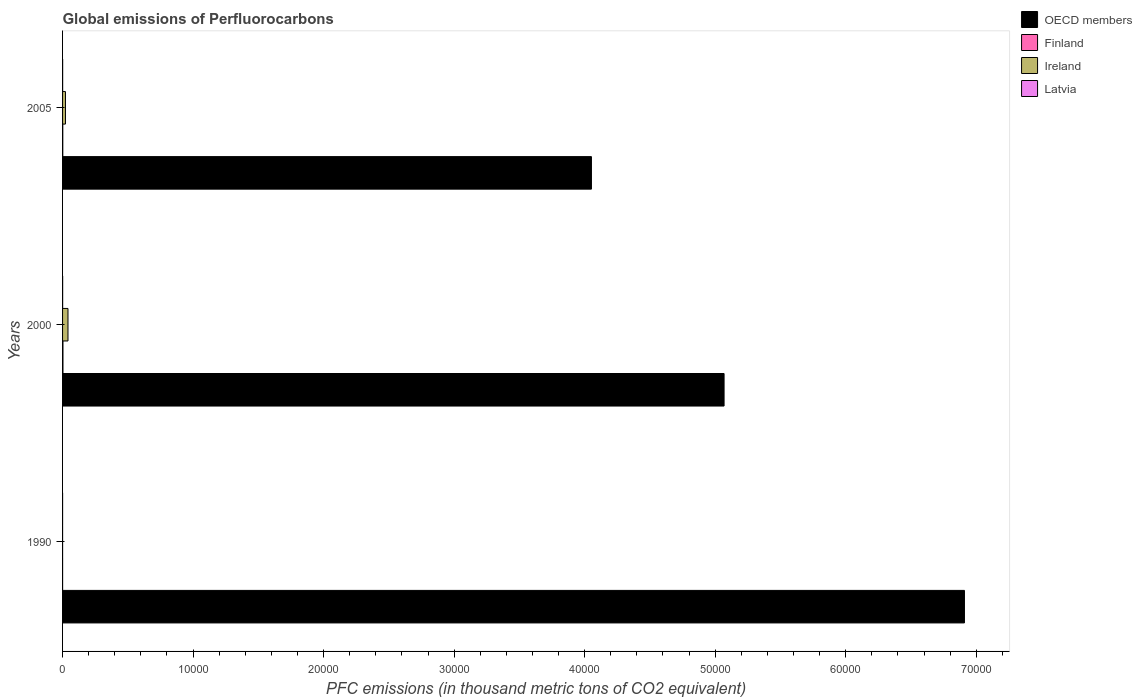How many different coloured bars are there?
Provide a short and direct response. 4. How many groups of bars are there?
Offer a terse response. 3. Are the number of bars on each tick of the Y-axis equal?
Your answer should be compact. Yes. What is the label of the 2nd group of bars from the top?
Make the answer very short. 2000. In how many cases, is the number of bars for a given year not equal to the number of legend labels?
Your answer should be very brief. 0. What is the global emissions of Perfluorocarbons in Ireland in 2005?
Your answer should be compact. 221.8. Across all years, what is the maximum global emissions of Perfluorocarbons in Latvia?
Your response must be concise. 5.7. Across all years, what is the minimum global emissions of Perfluorocarbons in OECD members?
Offer a very short reply. 4.05e+04. In which year was the global emissions of Perfluorocarbons in OECD members maximum?
Provide a succinct answer. 1990. What is the total global emissions of Perfluorocarbons in Ireland in the graph?
Ensure brevity in your answer.  638.8. What is the difference between the global emissions of Perfluorocarbons in Latvia in 1990 and the global emissions of Perfluorocarbons in OECD members in 2000?
Provide a succinct answer. -5.07e+04. What is the average global emissions of Perfluorocarbons in Latvia per year?
Make the answer very short. 3.97. In the year 2005, what is the difference between the global emissions of Perfluorocarbons in Finland and global emissions of Perfluorocarbons in OECD members?
Keep it short and to the point. -4.05e+04. In how many years, is the global emissions of Perfluorocarbons in OECD members greater than 58000 thousand metric tons?
Provide a succinct answer. 1. What is the ratio of the global emissions of Perfluorocarbons in OECD members in 2000 to that in 2005?
Your answer should be very brief. 1.25. Is the difference between the global emissions of Perfluorocarbons in Finland in 1990 and 2000 greater than the difference between the global emissions of Perfluorocarbons in OECD members in 1990 and 2000?
Your answer should be very brief. No. What is the difference between the highest and the second highest global emissions of Perfluorocarbons in Finland?
Ensure brevity in your answer.  13. What is the difference between the highest and the lowest global emissions of Perfluorocarbons in Finland?
Provide a short and direct response. 28. In how many years, is the global emissions of Perfluorocarbons in Ireland greater than the average global emissions of Perfluorocarbons in Ireland taken over all years?
Your response must be concise. 2. Is it the case that in every year, the sum of the global emissions of Perfluorocarbons in OECD members and global emissions of Perfluorocarbons in Latvia is greater than the sum of global emissions of Perfluorocarbons in Ireland and global emissions of Perfluorocarbons in Finland?
Offer a very short reply. No. How many years are there in the graph?
Your response must be concise. 3. What is the difference between two consecutive major ticks on the X-axis?
Offer a very short reply. 10000. Does the graph contain grids?
Provide a short and direct response. No. Where does the legend appear in the graph?
Your answer should be very brief. Top right. How many legend labels are there?
Your answer should be compact. 4. What is the title of the graph?
Provide a short and direct response. Global emissions of Perfluorocarbons. Does "Nigeria" appear as one of the legend labels in the graph?
Offer a very short reply. No. What is the label or title of the X-axis?
Your answer should be very brief. PFC emissions (in thousand metric tons of CO2 equivalent). What is the label or title of the Y-axis?
Your response must be concise. Years. What is the PFC emissions (in thousand metric tons of CO2 equivalent) in OECD members in 1990?
Keep it short and to the point. 6.91e+04. What is the PFC emissions (in thousand metric tons of CO2 equivalent) of Finland in 1990?
Ensure brevity in your answer.  1.7. What is the PFC emissions (in thousand metric tons of CO2 equivalent) of Ireland in 1990?
Your answer should be very brief. 1.4. What is the PFC emissions (in thousand metric tons of CO2 equivalent) in OECD members in 2000?
Provide a short and direct response. 5.07e+04. What is the PFC emissions (in thousand metric tons of CO2 equivalent) in Finland in 2000?
Offer a very short reply. 29.7. What is the PFC emissions (in thousand metric tons of CO2 equivalent) of Ireland in 2000?
Keep it short and to the point. 415.6. What is the PFC emissions (in thousand metric tons of CO2 equivalent) of OECD members in 2005?
Make the answer very short. 4.05e+04. What is the PFC emissions (in thousand metric tons of CO2 equivalent) of Ireland in 2005?
Offer a very short reply. 221.8. What is the PFC emissions (in thousand metric tons of CO2 equivalent) of Latvia in 2005?
Your answer should be compact. 5.5. Across all years, what is the maximum PFC emissions (in thousand metric tons of CO2 equivalent) in OECD members?
Your response must be concise. 6.91e+04. Across all years, what is the maximum PFC emissions (in thousand metric tons of CO2 equivalent) in Finland?
Offer a very short reply. 29.7. Across all years, what is the maximum PFC emissions (in thousand metric tons of CO2 equivalent) in Ireland?
Make the answer very short. 415.6. Across all years, what is the minimum PFC emissions (in thousand metric tons of CO2 equivalent) in OECD members?
Offer a very short reply. 4.05e+04. What is the total PFC emissions (in thousand metric tons of CO2 equivalent) in OECD members in the graph?
Your response must be concise. 1.60e+05. What is the total PFC emissions (in thousand metric tons of CO2 equivalent) of Finland in the graph?
Your response must be concise. 48.1. What is the total PFC emissions (in thousand metric tons of CO2 equivalent) in Ireland in the graph?
Offer a very short reply. 638.8. What is the total PFC emissions (in thousand metric tons of CO2 equivalent) of Latvia in the graph?
Your answer should be very brief. 11.9. What is the difference between the PFC emissions (in thousand metric tons of CO2 equivalent) in OECD members in 1990 and that in 2000?
Your response must be concise. 1.84e+04. What is the difference between the PFC emissions (in thousand metric tons of CO2 equivalent) of Ireland in 1990 and that in 2000?
Give a very brief answer. -414.2. What is the difference between the PFC emissions (in thousand metric tons of CO2 equivalent) in Latvia in 1990 and that in 2000?
Offer a terse response. -5. What is the difference between the PFC emissions (in thousand metric tons of CO2 equivalent) in OECD members in 1990 and that in 2005?
Keep it short and to the point. 2.86e+04. What is the difference between the PFC emissions (in thousand metric tons of CO2 equivalent) of Ireland in 1990 and that in 2005?
Ensure brevity in your answer.  -220.4. What is the difference between the PFC emissions (in thousand metric tons of CO2 equivalent) of OECD members in 2000 and that in 2005?
Offer a very short reply. 1.02e+04. What is the difference between the PFC emissions (in thousand metric tons of CO2 equivalent) in Finland in 2000 and that in 2005?
Your answer should be very brief. 13. What is the difference between the PFC emissions (in thousand metric tons of CO2 equivalent) of Ireland in 2000 and that in 2005?
Ensure brevity in your answer.  193.8. What is the difference between the PFC emissions (in thousand metric tons of CO2 equivalent) of Latvia in 2000 and that in 2005?
Your response must be concise. 0.2. What is the difference between the PFC emissions (in thousand metric tons of CO2 equivalent) in OECD members in 1990 and the PFC emissions (in thousand metric tons of CO2 equivalent) in Finland in 2000?
Keep it short and to the point. 6.91e+04. What is the difference between the PFC emissions (in thousand metric tons of CO2 equivalent) of OECD members in 1990 and the PFC emissions (in thousand metric tons of CO2 equivalent) of Ireland in 2000?
Offer a terse response. 6.87e+04. What is the difference between the PFC emissions (in thousand metric tons of CO2 equivalent) of OECD members in 1990 and the PFC emissions (in thousand metric tons of CO2 equivalent) of Latvia in 2000?
Offer a very short reply. 6.91e+04. What is the difference between the PFC emissions (in thousand metric tons of CO2 equivalent) in Finland in 1990 and the PFC emissions (in thousand metric tons of CO2 equivalent) in Ireland in 2000?
Your answer should be very brief. -413.9. What is the difference between the PFC emissions (in thousand metric tons of CO2 equivalent) in OECD members in 1990 and the PFC emissions (in thousand metric tons of CO2 equivalent) in Finland in 2005?
Offer a terse response. 6.91e+04. What is the difference between the PFC emissions (in thousand metric tons of CO2 equivalent) in OECD members in 1990 and the PFC emissions (in thousand metric tons of CO2 equivalent) in Ireland in 2005?
Provide a succinct answer. 6.89e+04. What is the difference between the PFC emissions (in thousand metric tons of CO2 equivalent) in OECD members in 1990 and the PFC emissions (in thousand metric tons of CO2 equivalent) in Latvia in 2005?
Ensure brevity in your answer.  6.91e+04. What is the difference between the PFC emissions (in thousand metric tons of CO2 equivalent) of Finland in 1990 and the PFC emissions (in thousand metric tons of CO2 equivalent) of Ireland in 2005?
Ensure brevity in your answer.  -220.1. What is the difference between the PFC emissions (in thousand metric tons of CO2 equivalent) in Finland in 1990 and the PFC emissions (in thousand metric tons of CO2 equivalent) in Latvia in 2005?
Provide a succinct answer. -3.8. What is the difference between the PFC emissions (in thousand metric tons of CO2 equivalent) of OECD members in 2000 and the PFC emissions (in thousand metric tons of CO2 equivalent) of Finland in 2005?
Your answer should be very brief. 5.07e+04. What is the difference between the PFC emissions (in thousand metric tons of CO2 equivalent) of OECD members in 2000 and the PFC emissions (in thousand metric tons of CO2 equivalent) of Ireland in 2005?
Give a very brief answer. 5.05e+04. What is the difference between the PFC emissions (in thousand metric tons of CO2 equivalent) in OECD members in 2000 and the PFC emissions (in thousand metric tons of CO2 equivalent) in Latvia in 2005?
Make the answer very short. 5.07e+04. What is the difference between the PFC emissions (in thousand metric tons of CO2 equivalent) in Finland in 2000 and the PFC emissions (in thousand metric tons of CO2 equivalent) in Ireland in 2005?
Keep it short and to the point. -192.1. What is the difference between the PFC emissions (in thousand metric tons of CO2 equivalent) of Finland in 2000 and the PFC emissions (in thousand metric tons of CO2 equivalent) of Latvia in 2005?
Ensure brevity in your answer.  24.2. What is the difference between the PFC emissions (in thousand metric tons of CO2 equivalent) in Ireland in 2000 and the PFC emissions (in thousand metric tons of CO2 equivalent) in Latvia in 2005?
Make the answer very short. 410.1. What is the average PFC emissions (in thousand metric tons of CO2 equivalent) of OECD members per year?
Ensure brevity in your answer.  5.34e+04. What is the average PFC emissions (in thousand metric tons of CO2 equivalent) of Finland per year?
Your answer should be compact. 16.03. What is the average PFC emissions (in thousand metric tons of CO2 equivalent) in Ireland per year?
Your response must be concise. 212.93. What is the average PFC emissions (in thousand metric tons of CO2 equivalent) of Latvia per year?
Your answer should be compact. 3.97. In the year 1990, what is the difference between the PFC emissions (in thousand metric tons of CO2 equivalent) in OECD members and PFC emissions (in thousand metric tons of CO2 equivalent) in Finland?
Your answer should be compact. 6.91e+04. In the year 1990, what is the difference between the PFC emissions (in thousand metric tons of CO2 equivalent) of OECD members and PFC emissions (in thousand metric tons of CO2 equivalent) of Ireland?
Offer a terse response. 6.91e+04. In the year 1990, what is the difference between the PFC emissions (in thousand metric tons of CO2 equivalent) in OECD members and PFC emissions (in thousand metric tons of CO2 equivalent) in Latvia?
Make the answer very short. 6.91e+04. In the year 1990, what is the difference between the PFC emissions (in thousand metric tons of CO2 equivalent) in Ireland and PFC emissions (in thousand metric tons of CO2 equivalent) in Latvia?
Ensure brevity in your answer.  0.7. In the year 2000, what is the difference between the PFC emissions (in thousand metric tons of CO2 equivalent) of OECD members and PFC emissions (in thousand metric tons of CO2 equivalent) of Finland?
Ensure brevity in your answer.  5.07e+04. In the year 2000, what is the difference between the PFC emissions (in thousand metric tons of CO2 equivalent) of OECD members and PFC emissions (in thousand metric tons of CO2 equivalent) of Ireland?
Give a very brief answer. 5.03e+04. In the year 2000, what is the difference between the PFC emissions (in thousand metric tons of CO2 equivalent) in OECD members and PFC emissions (in thousand metric tons of CO2 equivalent) in Latvia?
Offer a very short reply. 5.07e+04. In the year 2000, what is the difference between the PFC emissions (in thousand metric tons of CO2 equivalent) in Finland and PFC emissions (in thousand metric tons of CO2 equivalent) in Ireland?
Give a very brief answer. -385.9. In the year 2000, what is the difference between the PFC emissions (in thousand metric tons of CO2 equivalent) in Finland and PFC emissions (in thousand metric tons of CO2 equivalent) in Latvia?
Offer a very short reply. 24. In the year 2000, what is the difference between the PFC emissions (in thousand metric tons of CO2 equivalent) in Ireland and PFC emissions (in thousand metric tons of CO2 equivalent) in Latvia?
Make the answer very short. 409.9. In the year 2005, what is the difference between the PFC emissions (in thousand metric tons of CO2 equivalent) in OECD members and PFC emissions (in thousand metric tons of CO2 equivalent) in Finland?
Provide a succinct answer. 4.05e+04. In the year 2005, what is the difference between the PFC emissions (in thousand metric tons of CO2 equivalent) in OECD members and PFC emissions (in thousand metric tons of CO2 equivalent) in Ireland?
Your response must be concise. 4.03e+04. In the year 2005, what is the difference between the PFC emissions (in thousand metric tons of CO2 equivalent) in OECD members and PFC emissions (in thousand metric tons of CO2 equivalent) in Latvia?
Provide a succinct answer. 4.05e+04. In the year 2005, what is the difference between the PFC emissions (in thousand metric tons of CO2 equivalent) of Finland and PFC emissions (in thousand metric tons of CO2 equivalent) of Ireland?
Keep it short and to the point. -205.1. In the year 2005, what is the difference between the PFC emissions (in thousand metric tons of CO2 equivalent) of Finland and PFC emissions (in thousand metric tons of CO2 equivalent) of Latvia?
Provide a short and direct response. 11.2. In the year 2005, what is the difference between the PFC emissions (in thousand metric tons of CO2 equivalent) in Ireland and PFC emissions (in thousand metric tons of CO2 equivalent) in Latvia?
Offer a very short reply. 216.3. What is the ratio of the PFC emissions (in thousand metric tons of CO2 equivalent) of OECD members in 1990 to that in 2000?
Your answer should be very brief. 1.36. What is the ratio of the PFC emissions (in thousand metric tons of CO2 equivalent) in Finland in 1990 to that in 2000?
Your answer should be very brief. 0.06. What is the ratio of the PFC emissions (in thousand metric tons of CO2 equivalent) of Ireland in 1990 to that in 2000?
Your answer should be very brief. 0. What is the ratio of the PFC emissions (in thousand metric tons of CO2 equivalent) of Latvia in 1990 to that in 2000?
Offer a terse response. 0.12. What is the ratio of the PFC emissions (in thousand metric tons of CO2 equivalent) in OECD members in 1990 to that in 2005?
Keep it short and to the point. 1.71. What is the ratio of the PFC emissions (in thousand metric tons of CO2 equivalent) in Finland in 1990 to that in 2005?
Your answer should be very brief. 0.1. What is the ratio of the PFC emissions (in thousand metric tons of CO2 equivalent) in Ireland in 1990 to that in 2005?
Make the answer very short. 0.01. What is the ratio of the PFC emissions (in thousand metric tons of CO2 equivalent) of Latvia in 1990 to that in 2005?
Your response must be concise. 0.13. What is the ratio of the PFC emissions (in thousand metric tons of CO2 equivalent) of OECD members in 2000 to that in 2005?
Your response must be concise. 1.25. What is the ratio of the PFC emissions (in thousand metric tons of CO2 equivalent) in Finland in 2000 to that in 2005?
Offer a very short reply. 1.78. What is the ratio of the PFC emissions (in thousand metric tons of CO2 equivalent) in Ireland in 2000 to that in 2005?
Ensure brevity in your answer.  1.87. What is the ratio of the PFC emissions (in thousand metric tons of CO2 equivalent) in Latvia in 2000 to that in 2005?
Offer a terse response. 1.04. What is the difference between the highest and the second highest PFC emissions (in thousand metric tons of CO2 equivalent) in OECD members?
Your answer should be compact. 1.84e+04. What is the difference between the highest and the second highest PFC emissions (in thousand metric tons of CO2 equivalent) of Finland?
Offer a terse response. 13. What is the difference between the highest and the second highest PFC emissions (in thousand metric tons of CO2 equivalent) of Ireland?
Your answer should be very brief. 193.8. What is the difference between the highest and the second highest PFC emissions (in thousand metric tons of CO2 equivalent) in Latvia?
Your answer should be compact. 0.2. What is the difference between the highest and the lowest PFC emissions (in thousand metric tons of CO2 equivalent) in OECD members?
Ensure brevity in your answer.  2.86e+04. What is the difference between the highest and the lowest PFC emissions (in thousand metric tons of CO2 equivalent) in Finland?
Provide a short and direct response. 28. What is the difference between the highest and the lowest PFC emissions (in thousand metric tons of CO2 equivalent) in Ireland?
Your answer should be compact. 414.2. What is the difference between the highest and the lowest PFC emissions (in thousand metric tons of CO2 equivalent) of Latvia?
Offer a very short reply. 5. 